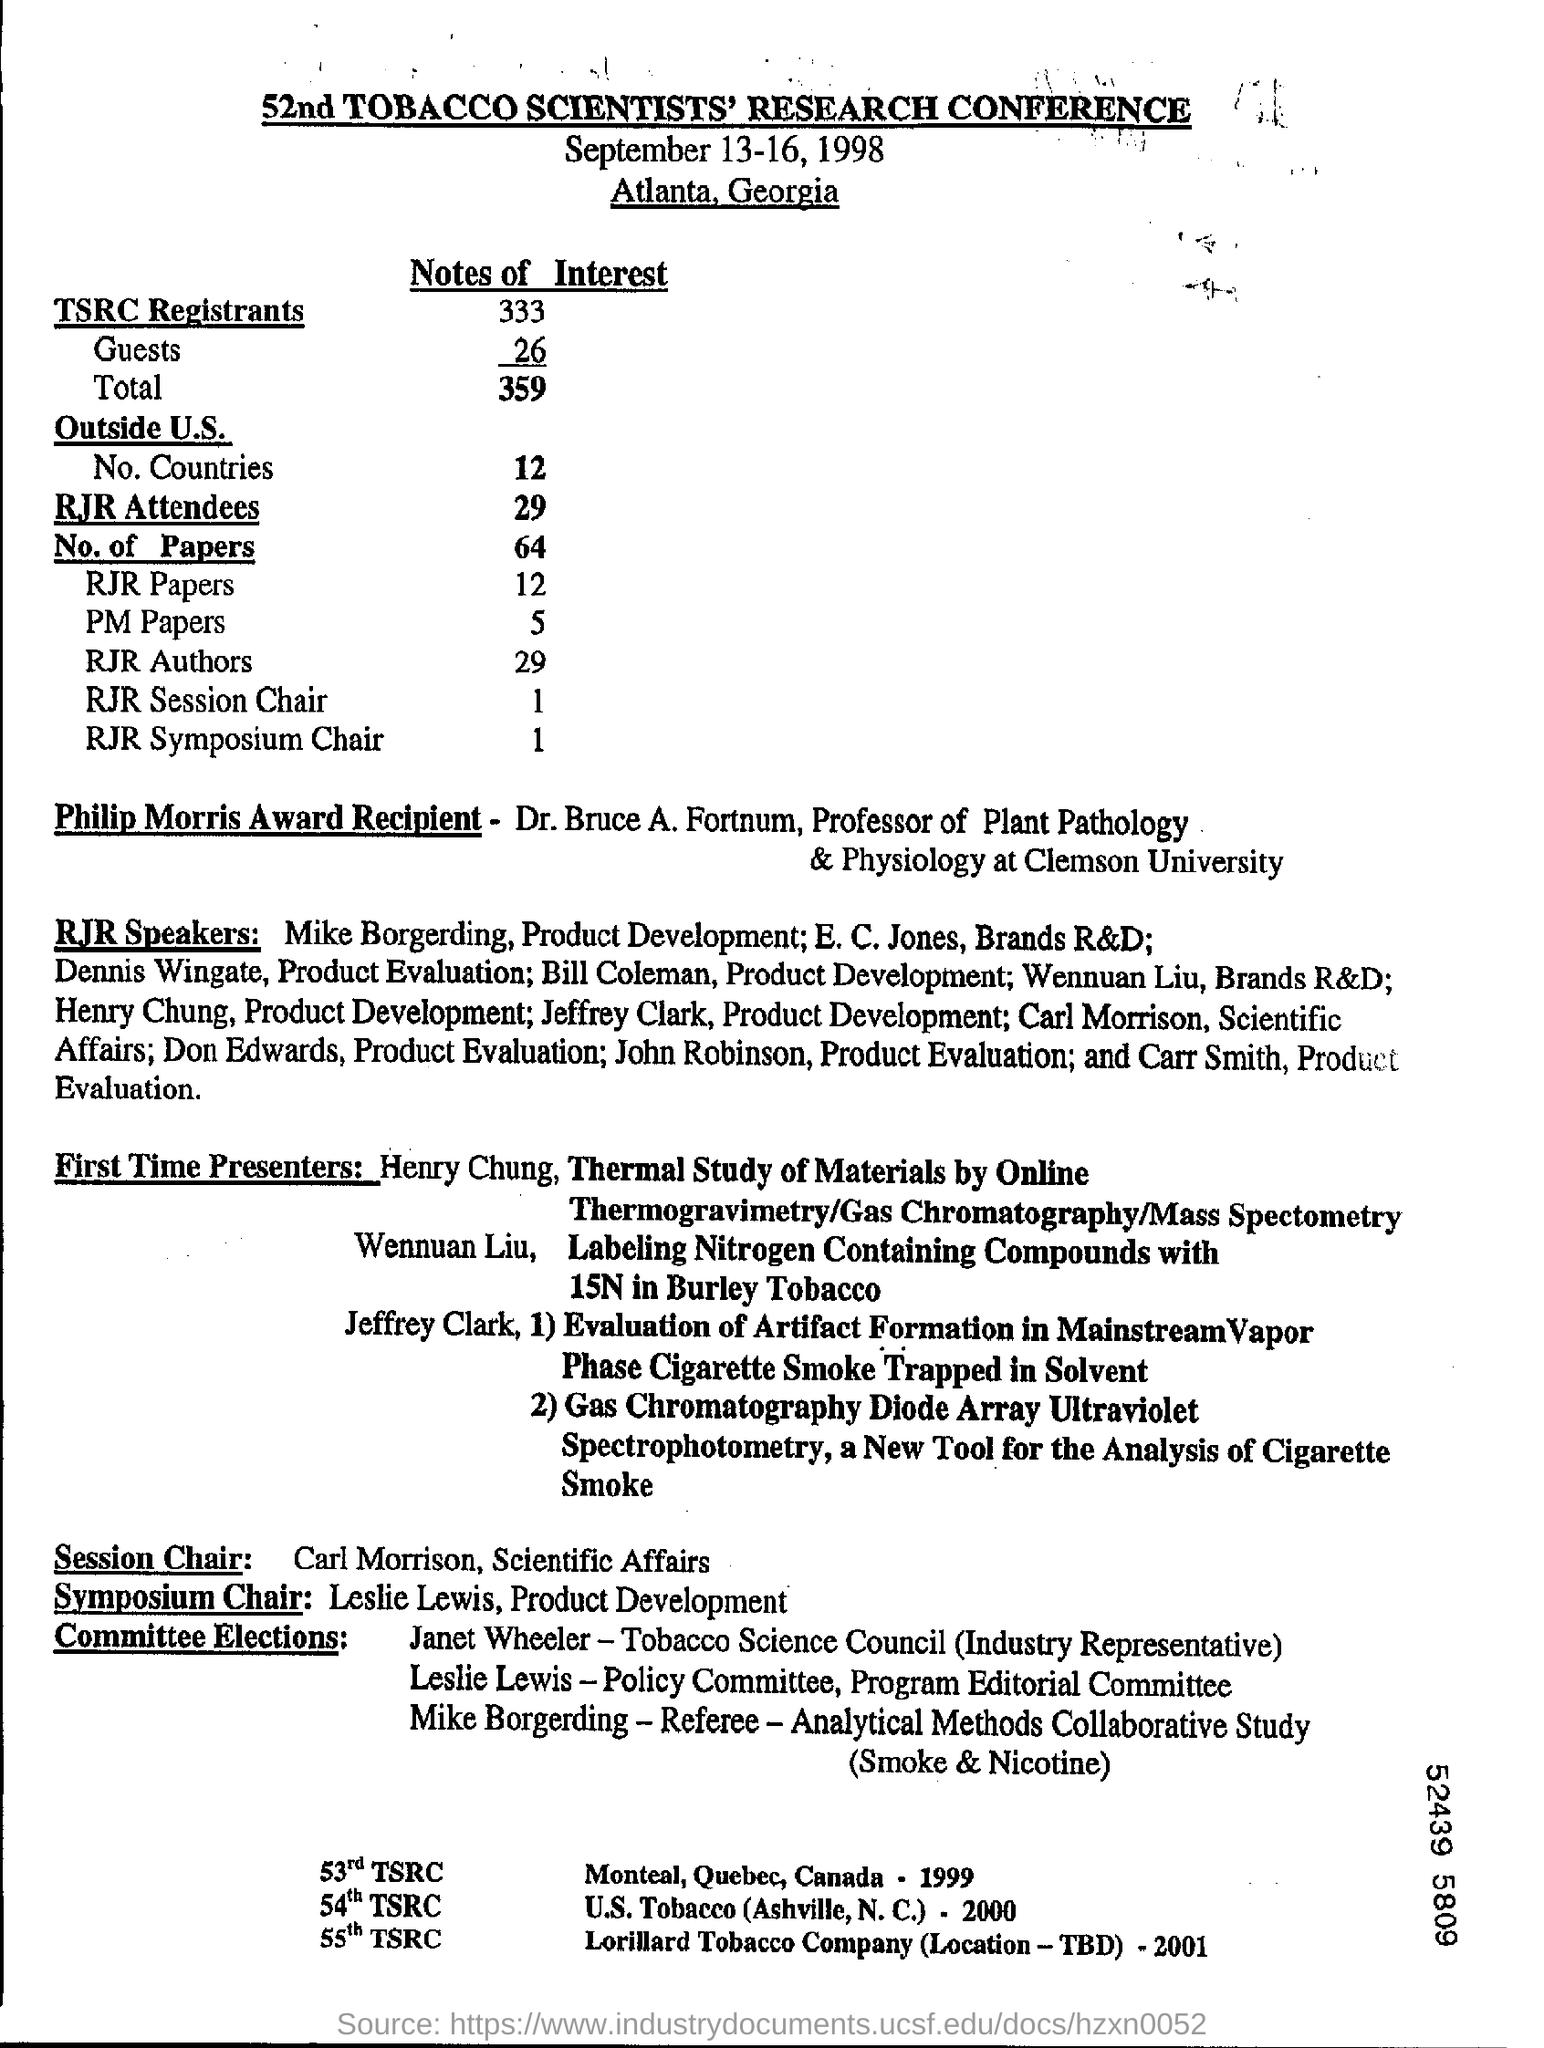What is the heading of the document?
Provide a short and direct response. 52nd TOBACCO SCIENTISTS' RESEARCH CONFERENCE. Where is this Conference located?
Give a very brief answer. Atlanta, Georgia. How many Guests are mentioned?
Ensure brevity in your answer.  26. How many RJR Symposium Chairs are mentioned?
Provide a short and direct response. 1. Who are present in the Session Chair?
Make the answer very short. Carl morrison, scientific affairs. 